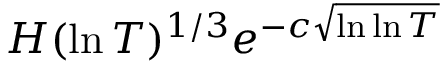<formula> <loc_0><loc_0><loc_500><loc_500>H ( \ln T ) ^ { 1 / 3 } e ^ { - c { \sqrt { \ln \ln T } } }</formula> 